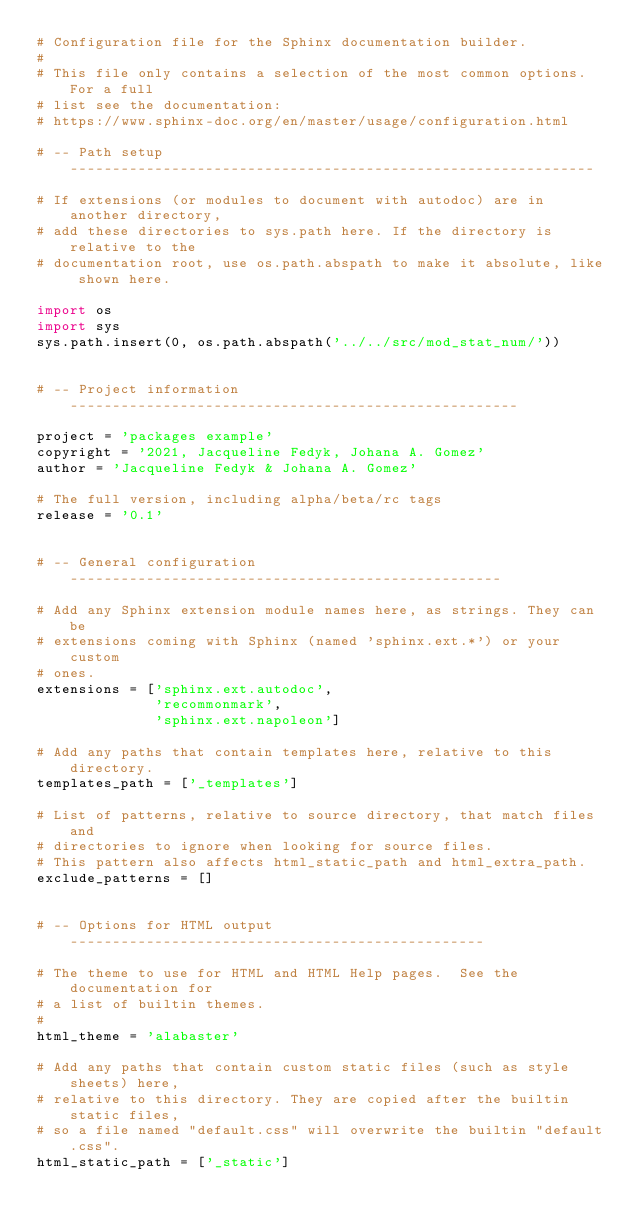Convert code to text. <code><loc_0><loc_0><loc_500><loc_500><_Python_># Configuration file for the Sphinx documentation builder.
#
# This file only contains a selection of the most common options. For a full
# list see the documentation:
# https://www.sphinx-doc.org/en/master/usage/configuration.html

# -- Path setup --------------------------------------------------------------

# If extensions (or modules to document with autodoc) are in another directory,
# add these directories to sys.path here. If the directory is relative to the
# documentation root, use os.path.abspath to make it absolute, like shown here.

import os
import sys
sys.path.insert(0, os.path.abspath('../../src/mod_stat_num/'))


# -- Project information -----------------------------------------------------

project = 'packages example'
copyright = '2021, Jacqueline Fedyk, Johana A. Gomez'
author = 'Jacqueline Fedyk & Johana A. Gomez'

# The full version, including alpha/beta/rc tags
release = '0.1'


# -- General configuration ---------------------------------------------------

# Add any Sphinx extension module names here, as strings. They can be
# extensions coming with Sphinx (named 'sphinx.ext.*') or your custom
# ones.
extensions = ['sphinx.ext.autodoc',
              'recommonmark',
              'sphinx.ext.napoleon']

# Add any paths that contain templates here, relative to this directory.
templates_path = ['_templates']

# List of patterns, relative to source directory, that match files and
# directories to ignore when looking for source files.
# This pattern also affects html_static_path and html_extra_path.
exclude_patterns = []


# -- Options for HTML output -------------------------------------------------

# The theme to use for HTML and HTML Help pages.  See the documentation for
# a list of builtin themes.
#
html_theme = 'alabaster'

# Add any paths that contain custom static files (such as style sheets) here,
# relative to this directory. They are copied after the builtin static files,
# so a file named "default.css" will overwrite the builtin "default.css".
html_static_path = ['_static']
</code> 